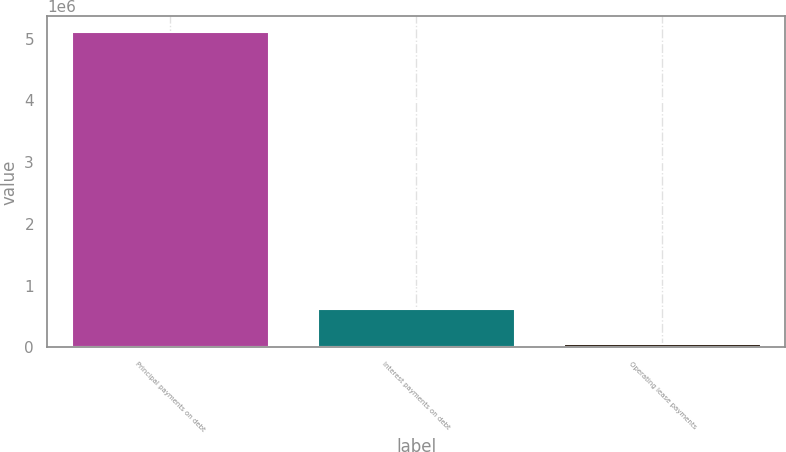<chart> <loc_0><loc_0><loc_500><loc_500><bar_chart><fcel>Principal payments on debt<fcel>Interest payments on debt<fcel>Operating lease payments<nl><fcel>5.10265e+06<fcel>626291<fcel>52944<nl></chart> 